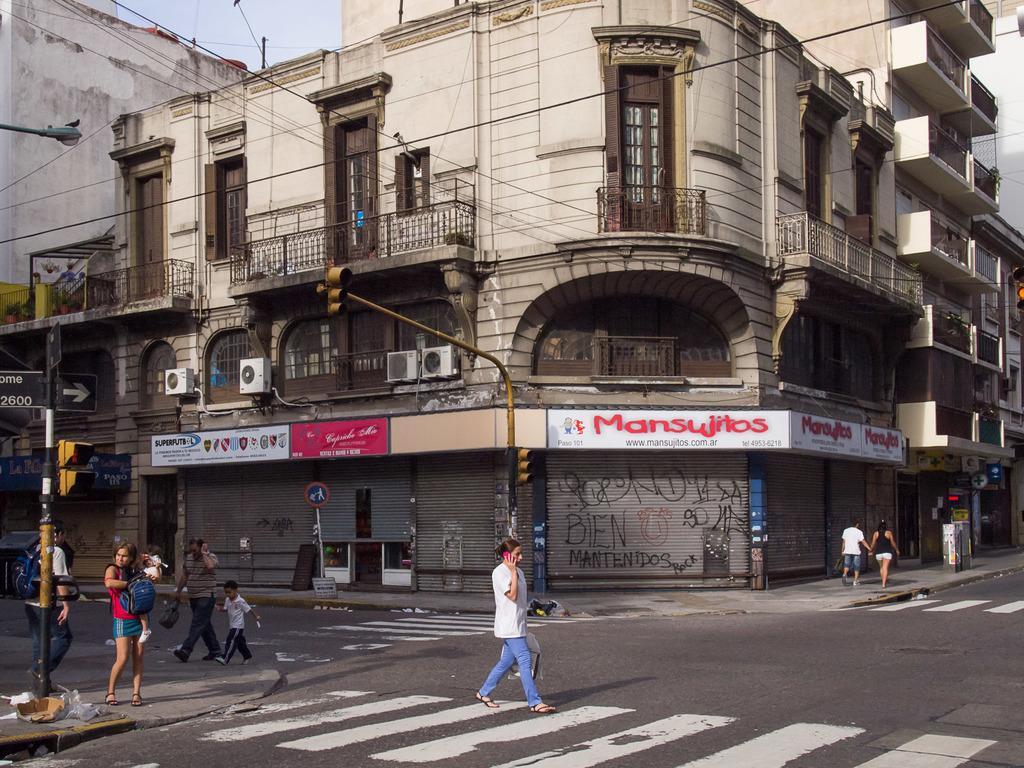Could you give a brief overview of what you see in this image? This is an outside view. Here I can see few people are walking on the road and footpath. On the left side there is a pole. In the background there are few buildings. At the top of the image I can see the sky. 